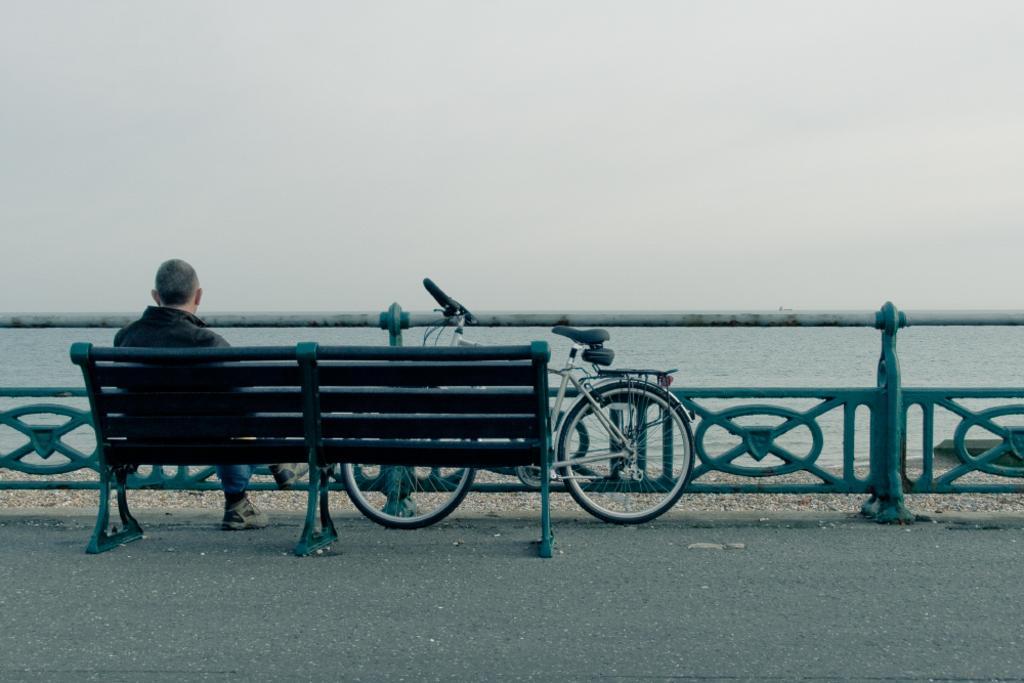How would you summarize this image in a sentence or two? On the left hand side of the image, there is a person sitting on a chair which is on the road. In front of the chair, there is a bicycle which is in stand position. In the background, there is water and sky. 